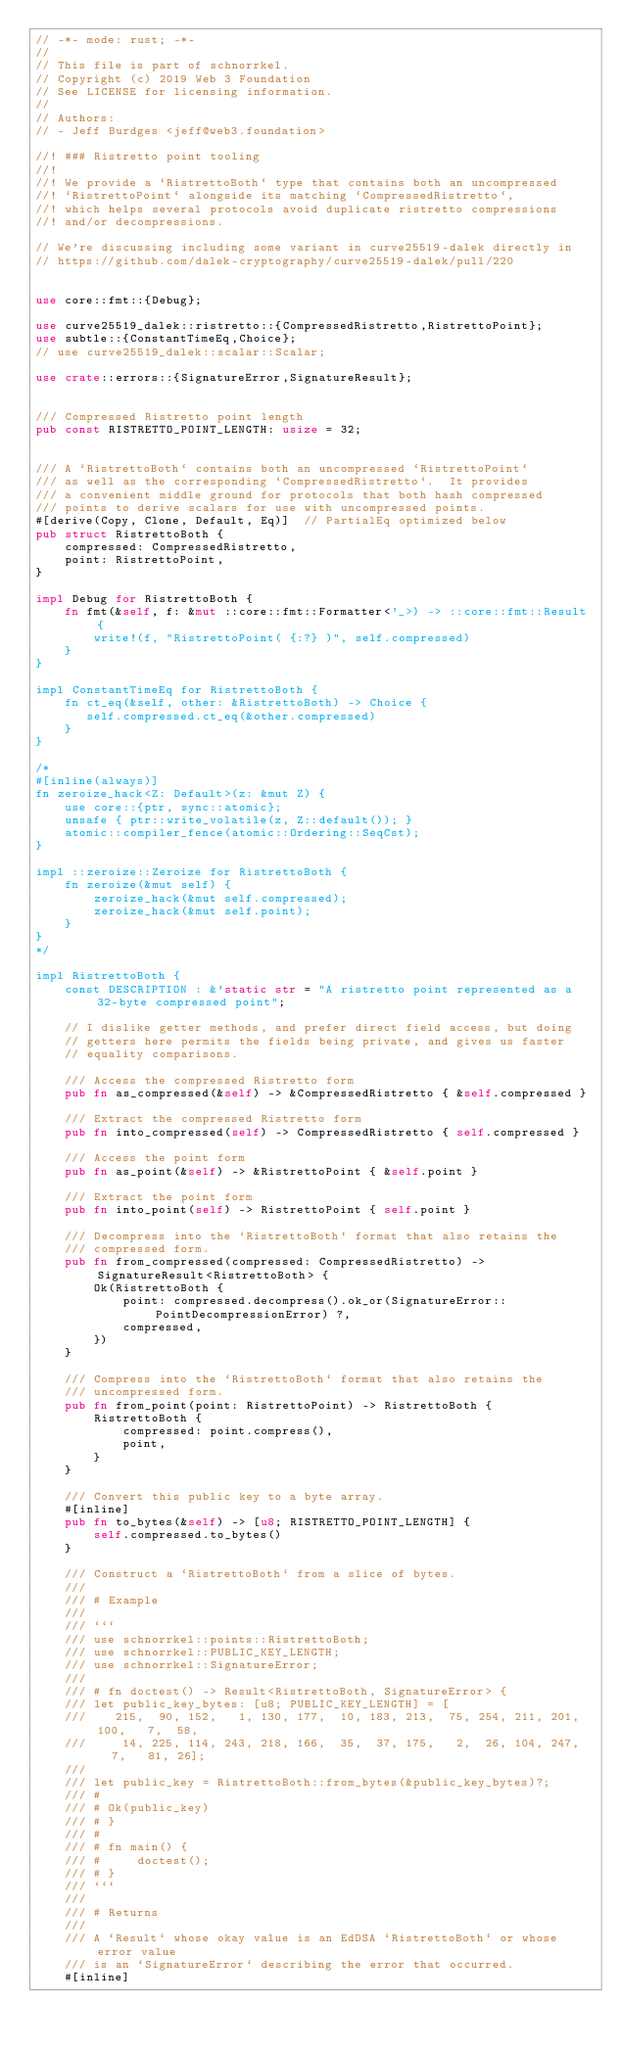Convert code to text. <code><loc_0><loc_0><loc_500><loc_500><_Rust_>// -*- mode: rust; -*-
//
// This file is part of schnorrkel.
// Copyright (c) 2019 Web 3 Foundation
// See LICENSE for licensing information.
//
// Authors:
// - Jeff Burdges <jeff@web3.foundation>

//! ### Ristretto point tooling
//!
//! We provide a `RistrettoBoth` type that contains both an uncompressed
//! `RistrettoPoint` alongside its matching `CompressedRistretto`,
//! which helps several protocols avoid duplicate ristretto compressions
//! and/or decompressions.

// We're discussing including some variant in curve25519-dalek directly in
// https://github.com/dalek-cryptography/curve25519-dalek/pull/220


use core::fmt::{Debug};

use curve25519_dalek::ristretto::{CompressedRistretto,RistrettoPoint};
use subtle::{ConstantTimeEq,Choice};
// use curve25519_dalek::scalar::Scalar;

use crate::errors::{SignatureError,SignatureResult};


/// Compressed Ristretto point length
pub const RISTRETTO_POINT_LENGTH: usize = 32;


/// A `RistrettoBoth` contains both an uncompressed `RistrettoPoint`
/// as well as the corresponding `CompressedRistretto`.  It provides
/// a convenient middle ground for protocols that both hash compressed
/// points to derive scalars for use with uncompressed points.
#[derive(Copy, Clone, Default, Eq)]  // PartialEq optimized below
pub struct RistrettoBoth {
    compressed: CompressedRistretto,
    point: RistrettoPoint,
}

impl Debug for RistrettoBoth {
    fn fmt(&self, f: &mut ::core::fmt::Formatter<'_>) -> ::core::fmt::Result {
        write!(f, "RistrettoPoint( {:?} )", self.compressed)
    }
}

impl ConstantTimeEq for RistrettoBoth {
    fn ct_eq(&self, other: &RistrettoBoth) -> Choice {
       self.compressed.ct_eq(&other.compressed)
    }
}

/*
#[inline(always)]
fn zeroize_hack<Z: Default>(z: &mut Z) {
    use core::{ptr, sync::atomic};
    unsafe { ptr::write_volatile(z, Z::default()); }
    atomic::compiler_fence(atomic::Ordering::SeqCst);
}

impl ::zeroize::Zeroize for RistrettoBoth {
    fn zeroize(&mut self) {
        zeroize_hack(&mut self.compressed);
        zeroize_hack(&mut self.point);
    }
}
*/

impl RistrettoBoth {
    const DESCRIPTION : &'static str = "A ristretto point represented as a 32-byte compressed point";

    // I dislike getter methods, and prefer direct field access, but doing
    // getters here permits the fields being private, and gives us faster
    // equality comparisons.

    /// Access the compressed Ristretto form
    pub fn as_compressed(&self) -> &CompressedRistretto { &self.compressed }

    /// Extract the compressed Ristretto form
    pub fn into_compressed(self) -> CompressedRistretto { self.compressed }

    /// Access the point form
    pub fn as_point(&self) -> &RistrettoPoint { &self.point }

    /// Extract the point form
    pub fn into_point(self) -> RistrettoPoint { self.point }

    /// Decompress into the `RistrettoBoth` format that also retains the
    /// compressed form.
    pub fn from_compressed(compressed: CompressedRistretto) -> SignatureResult<RistrettoBoth> {
        Ok(RistrettoBoth {
            point: compressed.decompress().ok_or(SignatureError::PointDecompressionError) ?,
            compressed,
        })
    }

    /// Compress into the `RistrettoBoth` format that also retains the
    /// uncompressed form.
    pub fn from_point(point: RistrettoPoint) -> RistrettoBoth {
        RistrettoBoth {
            compressed: point.compress(),
            point,
        }
    }

    /// Convert this public key to a byte array.
    #[inline]
    pub fn to_bytes(&self) -> [u8; RISTRETTO_POINT_LENGTH] {
        self.compressed.to_bytes()
    }

    /// Construct a `RistrettoBoth` from a slice of bytes.
    ///
    /// # Example
    ///
    /// ```
    /// use schnorrkel::points::RistrettoBoth;
    /// use schnorrkel::PUBLIC_KEY_LENGTH;
    /// use schnorrkel::SignatureError;
    ///
    /// # fn doctest() -> Result<RistrettoBoth, SignatureError> {
    /// let public_key_bytes: [u8; PUBLIC_KEY_LENGTH] = [
    ///    215,  90, 152,   1, 130, 177,  10, 183, 213,  75, 254, 211, 201, 100,   7,  58,
    ///     14, 225, 114, 243, 218, 166,  35,  37, 175,   2,  26, 104, 247,   7,   81, 26];
    ///
    /// let public_key = RistrettoBoth::from_bytes(&public_key_bytes)?;
    /// #
    /// # Ok(public_key)
    /// # }
    /// #
    /// # fn main() {
    /// #     doctest();
    /// # }
    /// ```
    ///
    /// # Returns
    ///
    /// A `Result` whose okay value is an EdDSA `RistrettoBoth` or whose error value
    /// is an `SignatureError` describing the error that occurred.
    #[inline]</code> 